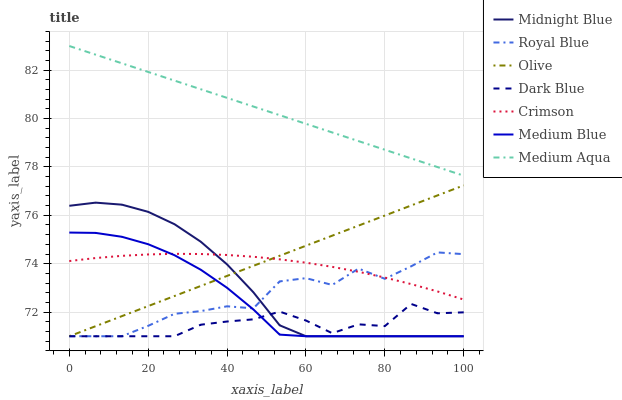Does Dark Blue have the minimum area under the curve?
Answer yes or no. Yes. Does Medium Aqua have the maximum area under the curve?
Answer yes or no. Yes. Does Medium Blue have the minimum area under the curve?
Answer yes or no. No. Does Medium Blue have the maximum area under the curve?
Answer yes or no. No. Is Medium Aqua the smoothest?
Answer yes or no. Yes. Is Royal Blue the roughest?
Answer yes or no. Yes. Is Dark Blue the smoothest?
Answer yes or no. No. Is Dark Blue the roughest?
Answer yes or no. No. Does Midnight Blue have the lowest value?
Answer yes or no. Yes. Does Medium Aqua have the lowest value?
Answer yes or no. No. Does Medium Aqua have the highest value?
Answer yes or no. Yes. Does Medium Blue have the highest value?
Answer yes or no. No. Is Royal Blue less than Medium Aqua?
Answer yes or no. Yes. Is Medium Aqua greater than Crimson?
Answer yes or no. Yes. Does Medium Blue intersect Royal Blue?
Answer yes or no. Yes. Is Medium Blue less than Royal Blue?
Answer yes or no. No. Is Medium Blue greater than Royal Blue?
Answer yes or no. No. Does Royal Blue intersect Medium Aqua?
Answer yes or no. No. 